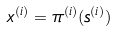<formula> <loc_0><loc_0><loc_500><loc_500>x ^ { ( i ) } = \pi ^ { ( i ) } ( s ^ { ( i ) } )</formula> 